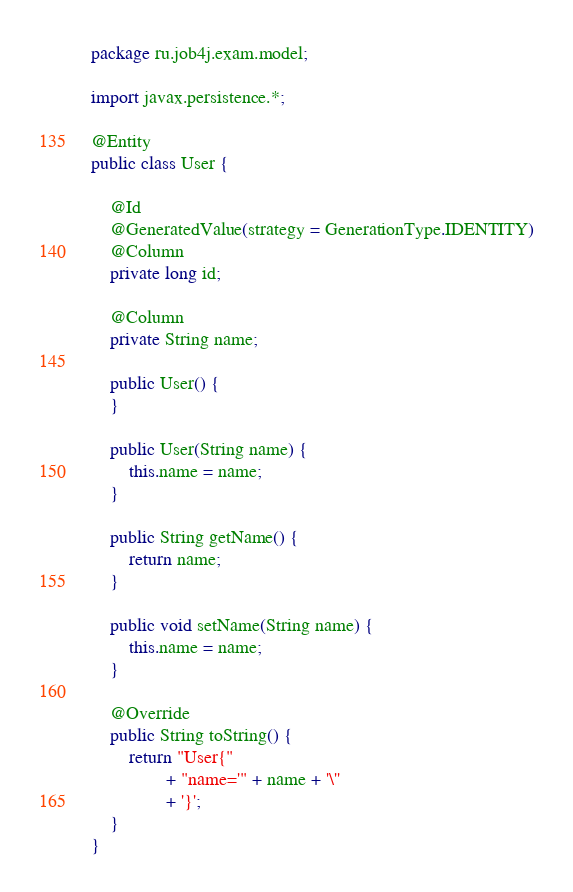Convert code to text. <code><loc_0><loc_0><loc_500><loc_500><_Java_>package ru.job4j.exam.model;

import javax.persistence.*;

@Entity
public class User {

    @Id
    @GeneratedValue(strategy = GenerationType.IDENTITY)
    @Column
    private long id;

    @Column
    private String name;

    public User() {
    }

    public User(String name) {
        this.name = name;
    }

    public String getName() {
        return name;
    }

    public void setName(String name) {
        this.name = name;
    }

    @Override
    public String toString() {
        return "User{"
                + "name='" + name + '\''
                + '}';
    }
}
</code> 